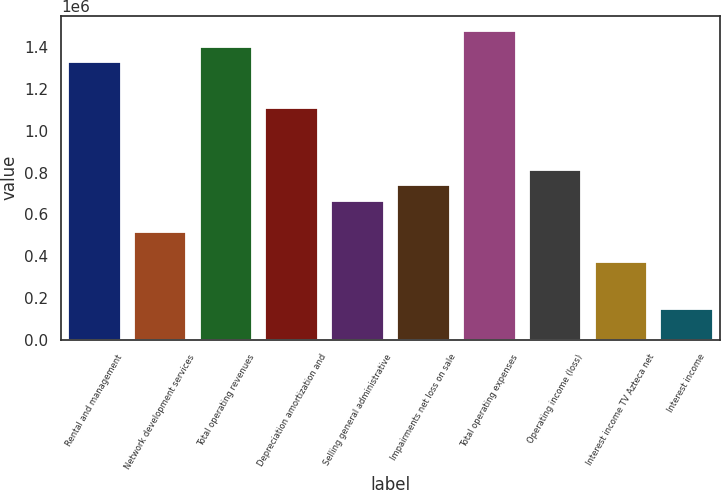Convert chart to OTSL. <chart><loc_0><loc_0><loc_500><loc_500><bar_chart><fcel>Rental and management<fcel>Network development services<fcel>Total operating revenues<fcel>Depreciation amortization and<fcel>Selling general administrative<fcel>Impairments net loss on sale<fcel>Total operating expenses<fcel>Operating income (loss)<fcel>Interest income TV Azteca net<fcel>Interest income<nl><fcel>1.32946e+06<fcel>517014<fcel>1.40332e+06<fcel>1.10788e+06<fcel>664731<fcel>738590<fcel>1.47718e+06<fcel>812449<fcel>369296<fcel>147719<nl></chart> 